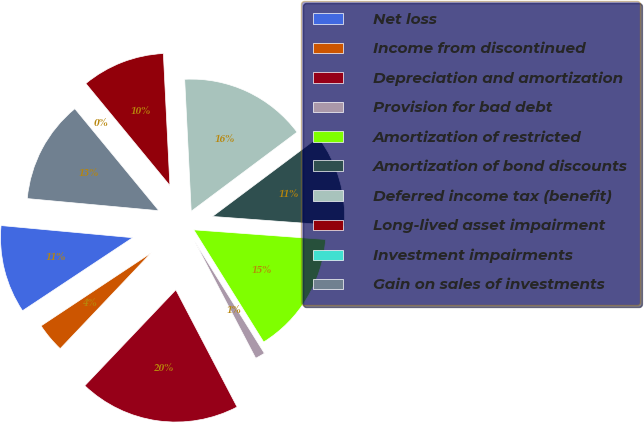Convert chart. <chart><loc_0><loc_0><loc_500><loc_500><pie_chart><fcel>Net loss<fcel>Income from discontinued<fcel>Depreciation and amortization<fcel>Provision for bad debt<fcel>Amortization of restricted<fcel>Amortization of bond discounts<fcel>Deferred income tax (benefit)<fcel>Long-lived asset impairment<fcel>Investment impairments<fcel>Gain on sales of investments<nl><fcel>10.78%<fcel>3.59%<fcel>19.76%<fcel>1.2%<fcel>14.97%<fcel>11.38%<fcel>15.57%<fcel>10.18%<fcel>0.0%<fcel>12.57%<nl></chart> 